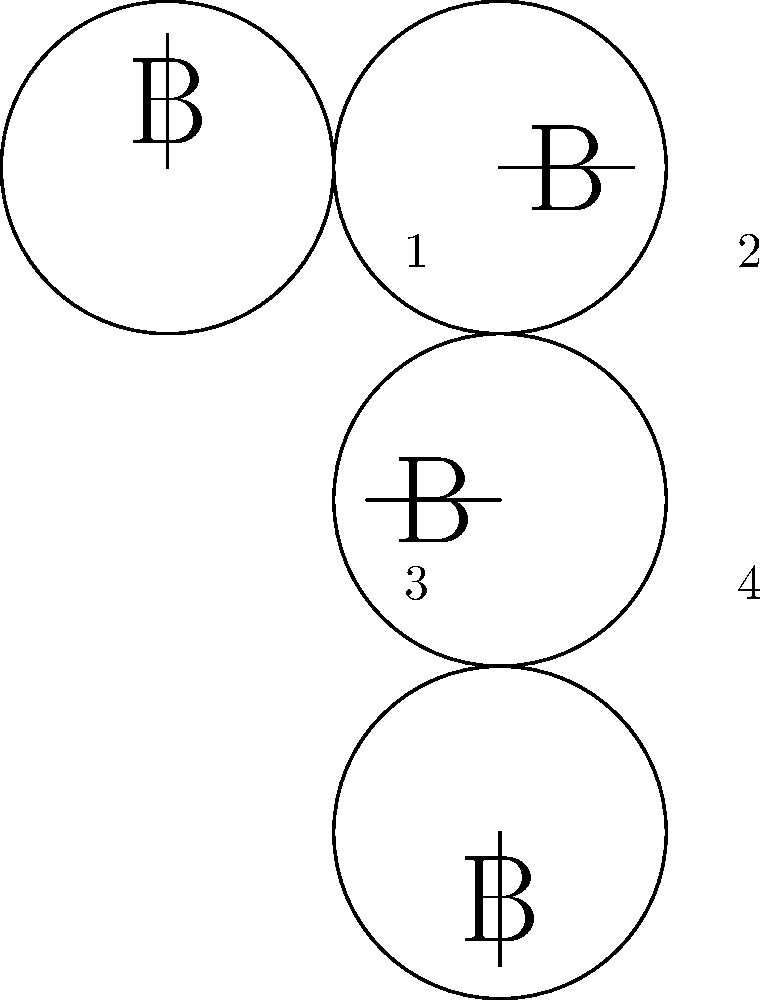As a new user of online banking services, you need to familiarize yourself with the bank's logo for security purposes. Which of the following options shows the correct orientation of the bank's logo as it would appear on the login page? To identify the correct orientation of the bank's logo, let's analyze each option:

1. Option 1 (top-left): The logo is in its original orientation. The 'B' is upright, and the line extends to the right.

2. Option 2 (top-right): The logo is rotated 90 degrees clockwise. The 'B' is lying on its side, and the line extends upwards.

3. Option 3 (bottom-left): The logo is rotated 180 degrees. The 'B' is upside down, and the line extends to the left.

4. Option 4 (bottom-right): The logo is rotated 270 degrees clockwise (or 90 degrees counterclockwise). The 'B' is lying on its side, and the line extends downwards.

In standard practice, logos are typically displayed in their original, upright orientation on login pages and other official materials. This ensures easy recognition and maintains brand consistency.

Therefore, the correct orientation of the bank's logo as it would appear on the login page is Option 1.
Answer: Option 1 